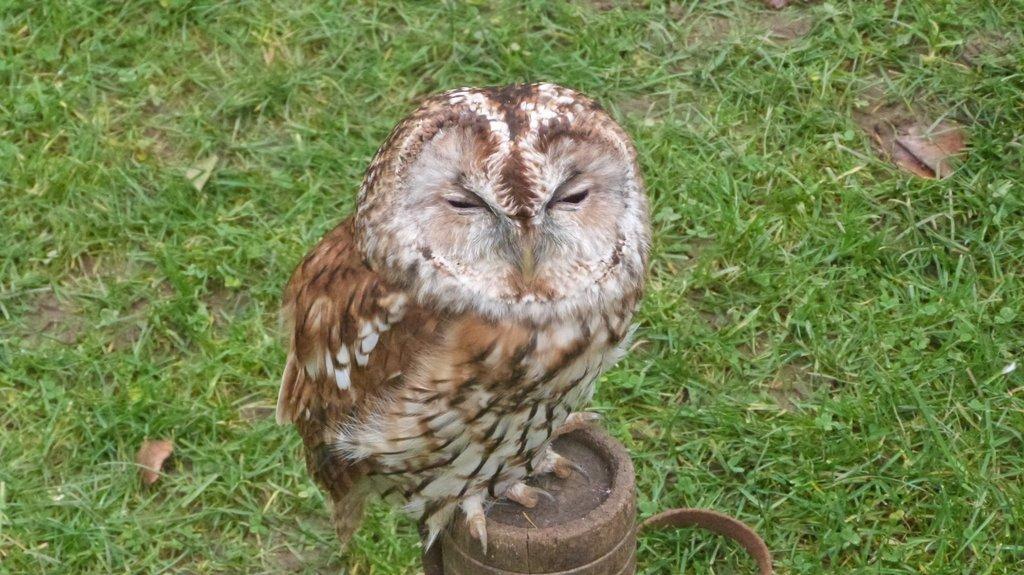Can you describe this image briefly? In this picture I can see there is a owl sitting on the wooden stick and there is grass and dry leaves on the floor. 